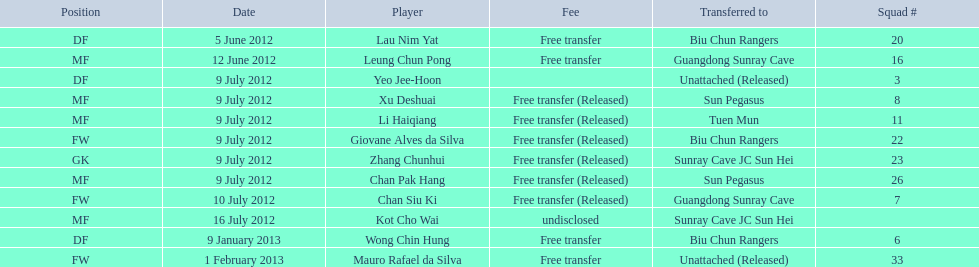Which players played during the 2012-13 south china aa season? Lau Nim Yat, Leung Chun Pong, Yeo Jee-Hoon, Xu Deshuai, Li Haiqiang, Giovane Alves da Silva, Zhang Chunhui, Chan Pak Hang, Chan Siu Ki, Kot Cho Wai, Wong Chin Hung, Mauro Rafael da Silva. Of these, which were free transfers that were not released? Lau Nim Yat, Leung Chun Pong, Wong Chin Hung, Mauro Rafael da Silva. Could you help me parse every detail presented in this table? {'header': ['Position', 'Date', 'Player', 'Fee', 'Transferred to', 'Squad #'], 'rows': [['DF', '5 June 2012', 'Lau Nim Yat', 'Free transfer', 'Biu Chun Rangers', '20'], ['MF', '12 June 2012', 'Leung Chun Pong', 'Free transfer', 'Guangdong Sunray Cave', '16'], ['DF', '9 July 2012', 'Yeo Jee-Hoon', '', 'Unattached (Released)', '3'], ['MF', '9 July 2012', 'Xu Deshuai', 'Free transfer (Released)', 'Sun Pegasus', '8'], ['MF', '9 July 2012', 'Li Haiqiang', 'Free transfer (Released)', 'Tuen Mun', '11'], ['FW', '9 July 2012', 'Giovane Alves da Silva', 'Free transfer (Released)', 'Biu Chun Rangers', '22'], ['GK', '9 July 2012', 'Zhang Chunhui', 'Free transfer (Released)', 'Sunray Cave JC Sun Hei', '23'], ['MF', '9 July 2012', 'Chan Pak Hang', 'Free transfer (Released)', 'Sun Pegasus', '26'], ['FW', '10 July 2012', 'Chan Siu Ki', 'Free transfer (Released)', 'Guangdong Sunray Cave', '7'], ['MF', '16 July 2012', 'Kot Cho Wai', 'undisclosed', 'Sunray Cave JC Sun Hei', ''], ['DF', '9 January 2013', 'Wong Chin Hung', 'Free transfer', 'Biu Chun Rangers', '6'], ['FW', '1 February 2013', 'Mauro Rafael da Silva', 'Free transfer', 'Unattached (Released)', '33']]} Of these, which were in squad # 6? Wong Chin Hung. What was the date of his transfer? 9 January 2013. 